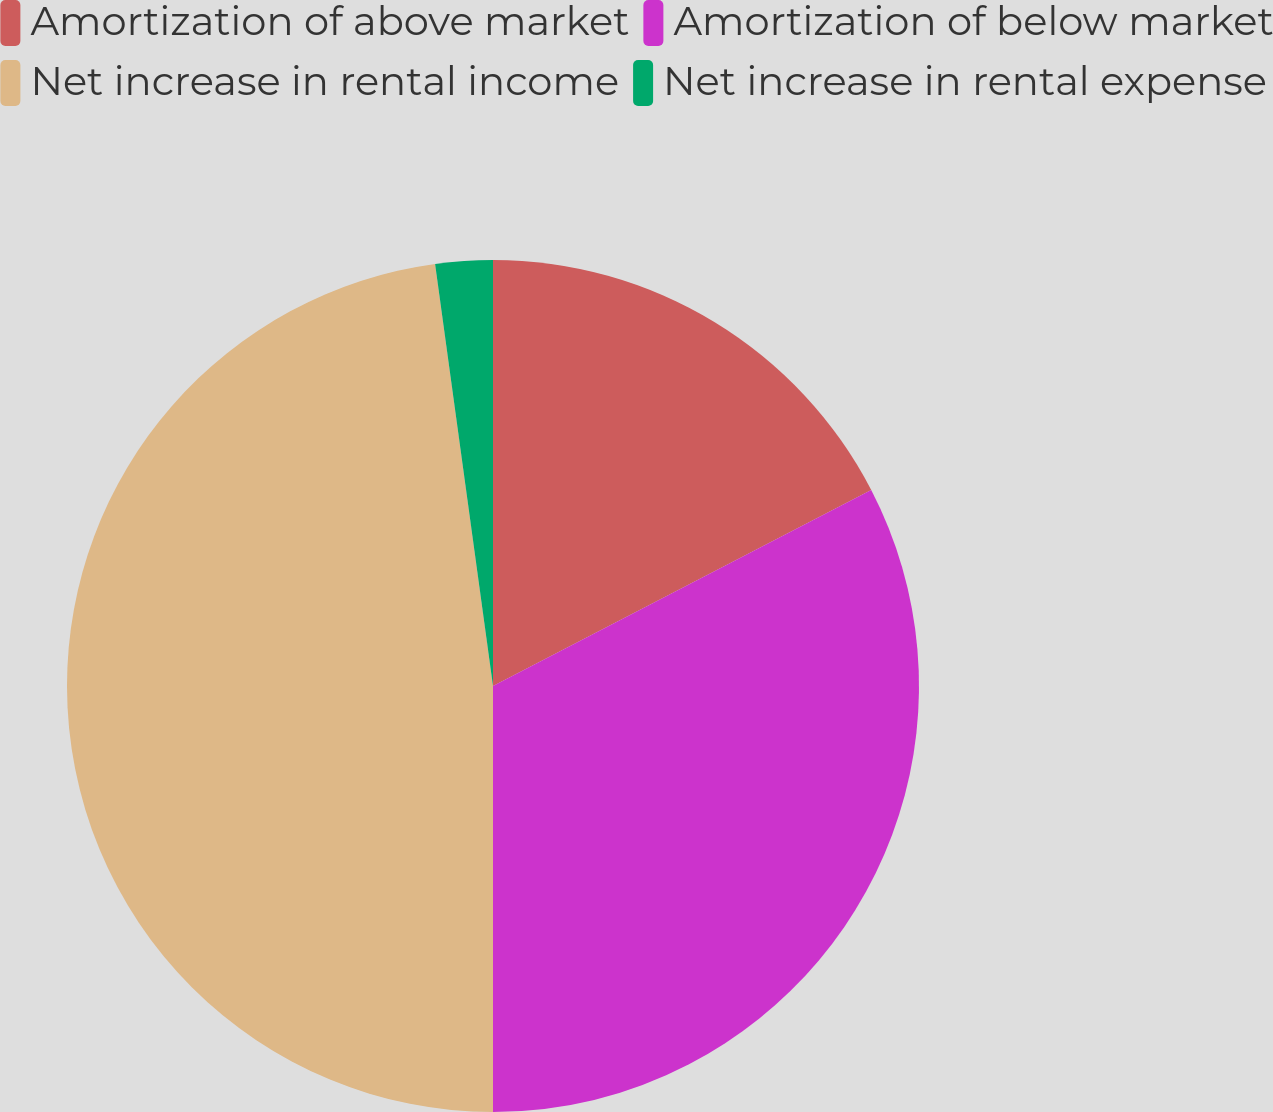Convert chart to OTSL. <chart><loc_0><loc_0><loc_500><loc_500><pie_chart><fcel>Amortization of above market<fcel>Amortization of below market<fcel>Net increase in rental income<fcel>Net increase in rental expense<nl><fcel>17.39%<fcel>32.61%<fcel>47.83%<fcel>2.17%<nl></chart> 